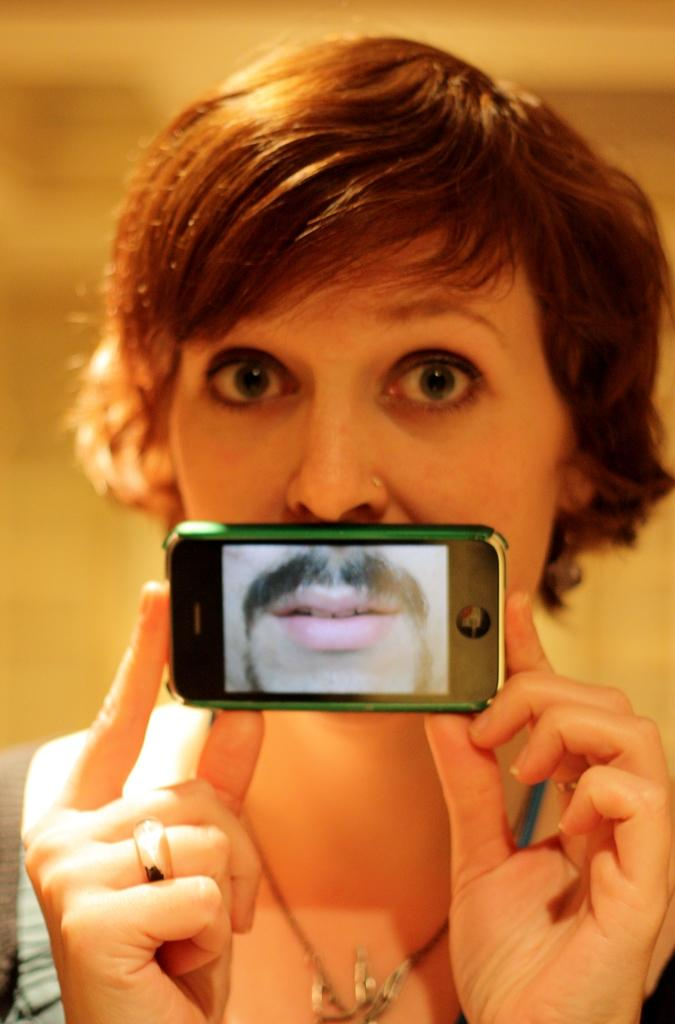What is the person holding in the image? The person is holding a mobile in the image. What direction is the person looking in? The person is looking forward in the image. What type of bubble can be seen in the person's mouth in the image? There is no bubble present in the person's mouth in the image. 